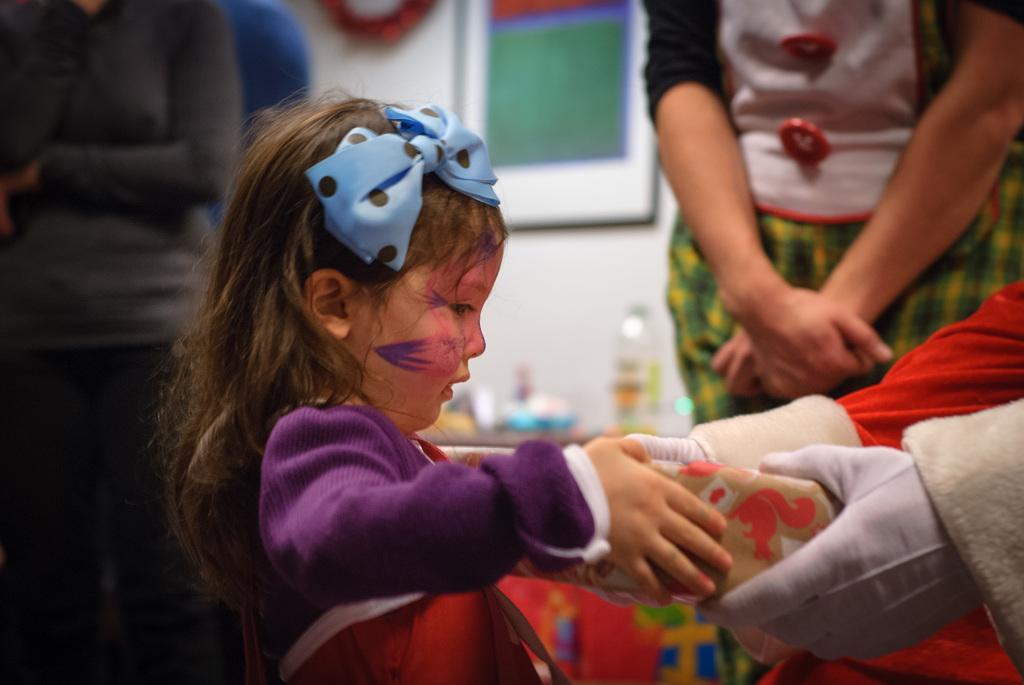Can you describe this image briefly? In this image, we can see a kid wearing costume and there is a man wearing gloves, are holding an object. In the background, there are some other people and we can see some objects and boards on the wall. 